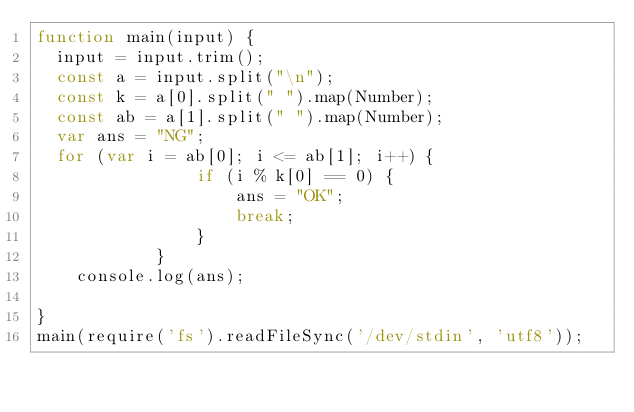Convert code to text. <code><loc_0><loc_0><loc_500><loc_500><_JavaScript_>function main(input) {
  input = input.trim();
  const a = input.split("\n");
  const k = a[0].split(" ").map(Number);
  const ab = a[1].split(" ").map(Number);
  var ans = "NG";
  for (var i = ab[0]; i <= ab[1]; i++) {
				if (i % k[0] == 0) {
					ans = "OK";
					break;
				}
			}
	console.log(ans);
  
}
main(require('fs').readFileSync('/dev/stdin', 'utf8'));</code> 